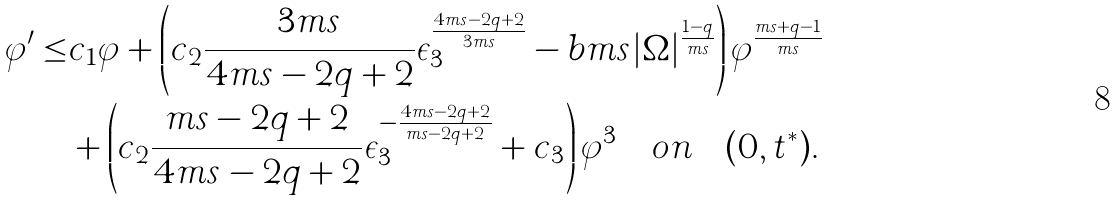Convert formula to latex. <formula><loc_0><loc_0><loc_500><loc_500>\varphi ^ { \prime } \leq & c _ { 1 } \varphi + \left ( c _ { 2 } \frac { 3 m s } { 4 m s - 2 q + 2 } \epsilon _ { 3 } ^ { \frac { 4 m s - 2 q + 2 } { 3 m s } } - b m s | \Omega | ^ { \frac { 1 - q } { m s } } \right ) \varphi ^ { \frac { m s + q - 1 } { m s } } \\ & + \left ( c _ { 2 } \frac { m s - 2 q + 2 } { 4 m s - 2 q + 2 } \epsilon _ { 3 } ^ { - \frac { 4 m s - 2 q + 2 } { m s - 2 q + 2 } } + c _ { 3 } \right ) \varphi ^ { 3 } \quad o n \quad ( 0 , t ^ { * } ) .</formula> 